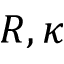Convert formula to latex. <formula><loc_0><loc_0><loc_500><loc_500>R , \kappa</formula> 